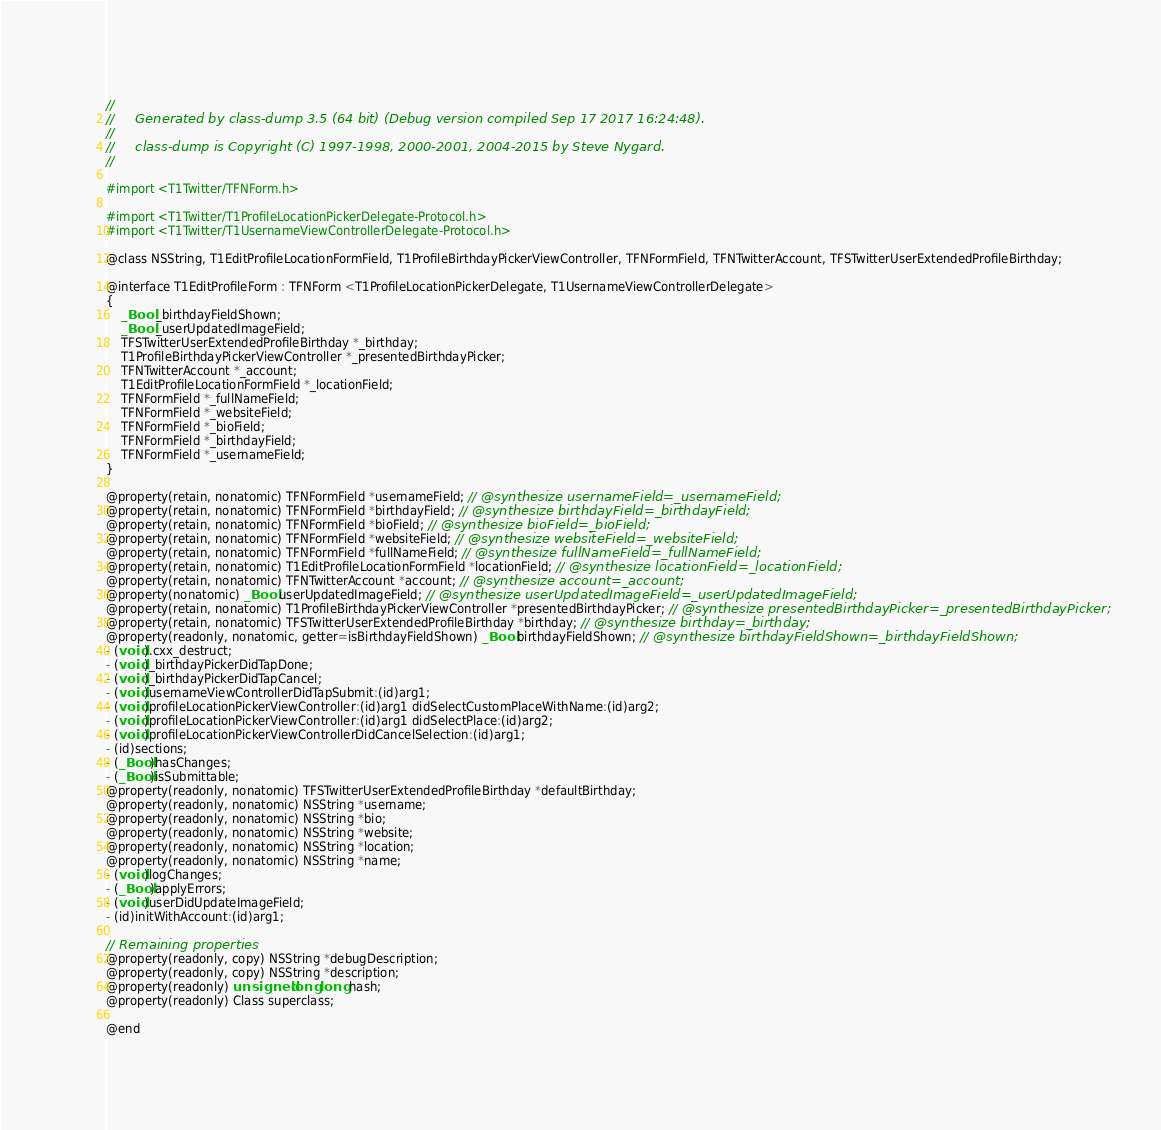Convert code to text. <code><loc_0><loc_0><loc_500><loc_500><_C_>//
//     Generated by class-dump 3.5 (64 bit) (Debug version compiled Sep 17 2017 16:24:48).
//
//     class-dump is Copyright (C) 1997-1998, 2000-2001, 2004-2015 by Steve Nygard.
//

#import <T1Twitter/TFNForm.h>

#import <T1Twitter/T1ProfileLocationPickerDelegate-Protocol.h>
#import <T1Twitter/T1UsernameViewControllerDelegate-Protocol.h>

@class NSString, T1EditProfileLocationFormField, T1ProfileBirthdayPickerViewController, TFNFormField, TFNTwitterAccount, TFSTwitterUserExtendedProfileBirthday;

@interface T1EditProfileForm : TFNForm <T1ProfileLocationPickerDelegate, T1UsernameViewControllerDelegate>
{
    _Bool _birthdayFieldShown;
    _Bool _userUpdatedImageField;
    TFSTwitterUserExtendedProfileBirthday *_birthday;
    T1ProfileBirthdayPickerViewController *_presentedBirthdayPicker;
    TFNTwitterAccount *_account;
    T1EditProfileLocationFormField *_locationField;
    TFNFormField *_fullNameField;
    TFNFormField *_websiteField;
    TFNFormField *_bioField;
    TFNFormField *_birthdayField;
    TFNFormField *_usernameField;
}

@property(retain, nonatomic) TFNFormField *usernameField; // @synthesize usernameField=_usernameField;
@property(retain, nonatomic) TFNFormField *birthdayField; // @synthesize birthdayField=_birthdayField;
@property(retain, nonatomic) TFNFormField *bioField; // @synthesize bioField=_bioField;
@property(retain, nonatomic) TFNFormField *websiteField; // @synthesize websiteField=_websiteField;
@property(retain, nonatomic) TFNFormField *fullNameField; // @synthesize fullNameField=_fullNameField;
@property(retain, nonatomic) T1EditProfileLocationFormField *locationField; // @synthesize locationField=_locationField;
@property(retain, nonatomic) TFNTwitterAccount *account; // @synthesize account=_account;
@property(nonatomic) _Bool userUpdatedImageField; // @synthesize userUpdatedImageField=_userUpdatedImageField;
@property(retain, nonatomic) T1ProfileBirthdayPickerViewController *presentedBirthdayPicker; // @synthesize presentedBirthdayPicker=_presentedBirthdayPicker;
@property(retain, nonatomic) TFSTwitterUserExtendedProfileBirthday *birthday; // @synthesize birthday=_birthday;
@property(readonly, nonatomic, getter=isBirthdayFieldShown) _Bool birthdayFieldShown; // @synthesize birthdayFieldShown=_birthdayFieldShown;
- (void).cxx_destruct;
- (void)_birthdayPickerDidTapDone;
- (void)_birthdayPickerDidTapCancel;
- (void)usernameViewControllerDidTapSubmit:(id)arg1;
- (void)profileLocationPickerViewController:(id)arg1 didSelectCustomPlaceWithName:(id)arg2;
- (void)profileLocationPickerViewController:(id)arg1 didSelectPlace:(id)arg2;
- (void)profileLocationPickerViewControllerDidCancelSelection:(id)arg1;
- (id)sections;
- (_Bool)hasChanges;
- (_Bool)isSubmittable;
@property(readonly, nonatomic) TFSTwitterUserExtendedProfileBirthday *defaultBirthday;
@property(readonly, nonatomic) NSString *username;
@property(readonly, nonatomic) NSString *bio;
@property(readonly, nonatomic) NSString *website;
@property(readonly, nonatomic) NSString *location;
@property(readonly, nonatomic) NSString *name;
- (void)logChanges;
- (_Bool)applyErrors;
- (void)userDidUpdateImageField;
- (id)initWithAccount:(id)arg1;

// Remaining properties
@property(readonly, copy) NSString *debugDescription;
@property(readonly, copy) NSString *description;
@property(readonly) unsigned long long hash;
@property(readonly) Class superclass;

@end

</code> 